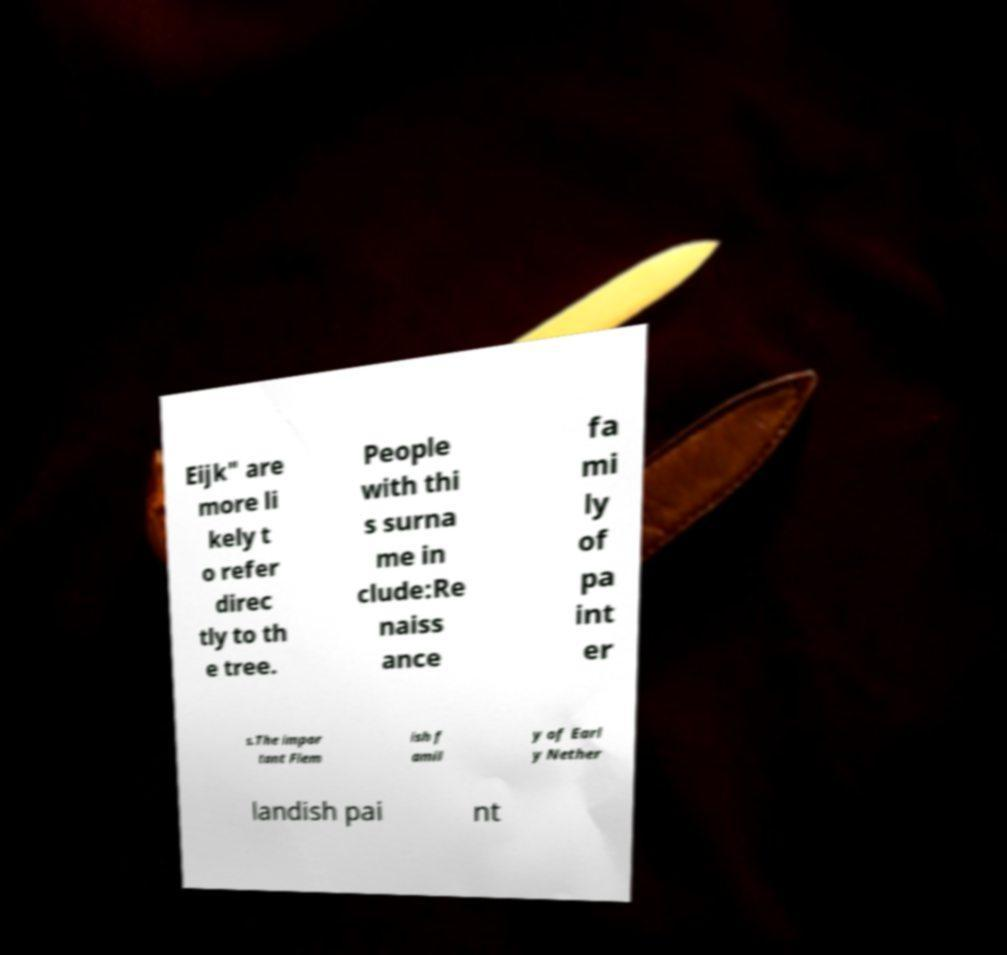For documentation purposes, I need the text within this image transcribed. Could you provide that? Eijk" are more li kely t o refer direc tly to th e tree. People with thi s surna me in clude:Re naiss ance fa mi ly of pa int er s.The impor tant Flem ish f amil y of Earl y Nether landish pai nt 